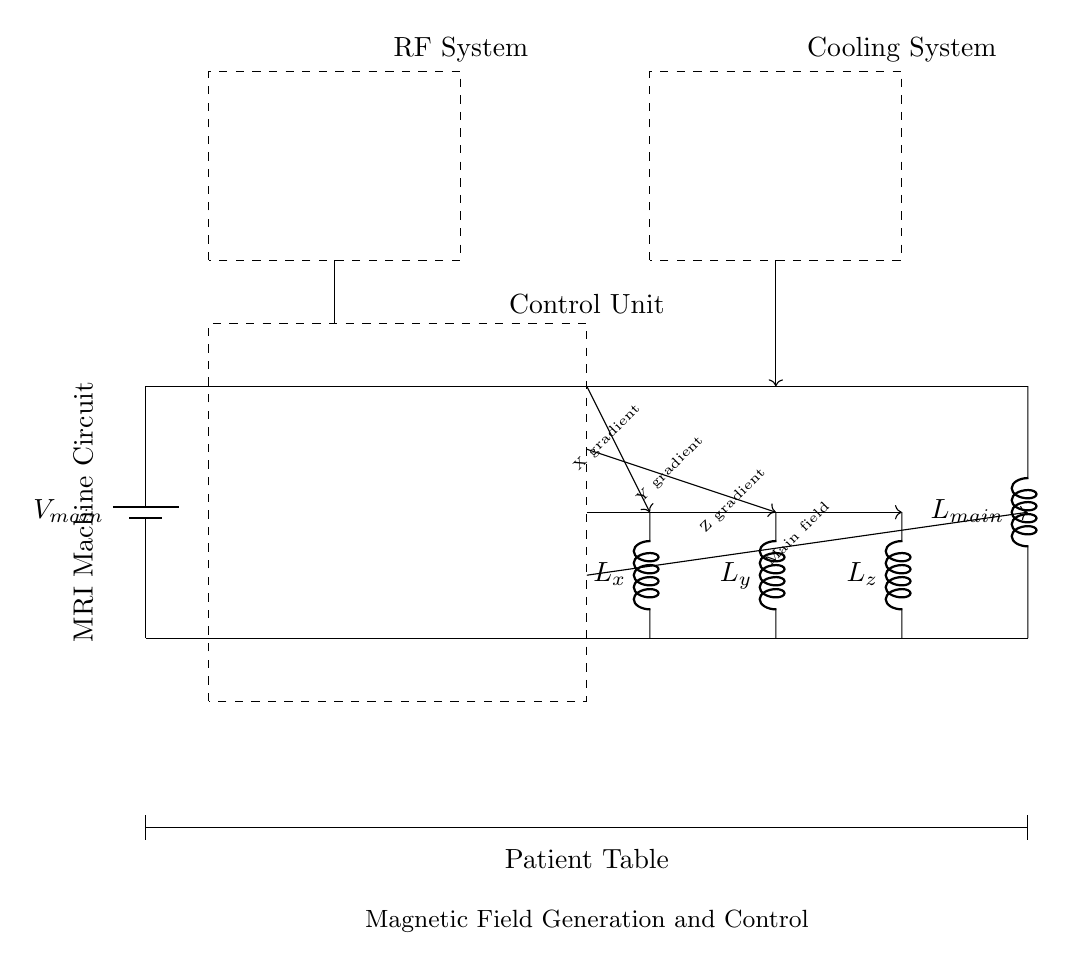What is the power supply voltage? The circuit diagram shows a battery labeled as V_main, which indicates the primary voltage source for the system.
Answer: V_main How many gradient coils are present in the circuit? The diagram clearly indicates three distinct inductors labeled as L_x, L_y, and L_z, representing the three gradient coils for X, Y, and Z directions respectively.
Answer: Three What is the function of the RF system in the circuit? The RF system is represented as a dashed rectangle located at the top left of the diagram. In MRI machines, the RF system is used for radiofrequency pulse generation and signal detection.
Answer: Radiofrequency pulse generation What do the arrows associated with the gradient coils represent? The arrows labeled X gradient, Y gradient, Z gradient, and Main field indicate control signals directing the operation of the respective coils for magnetic gradient generation. Each arrow points from the control unit to a specific coil.
Answer: Control signals What does the dashed rectangle labeled as "Cooling System" signify? The dashed rectangle labeled 'Cooling System' indicates a compartment necessary for maintaining the temperature of the MRI machine, particularly for the gradient coils, which generate heat during operation.
Answer: Temperature regulation Which component connects the main power supply to the rest of the circuit? The circuit connections show that the main power supply line connects directly to both the control unit and the main magnetic field coil, indicating it serves as the source for these components.
Answer: Main power supply What would happen if one of the gradient coils fails? If one of the gradient coils (L_x, L_y, or L_z) fails, the corresponding directional gradient generation would be compromised, which could lead to insufficient image resolution or distortions in MRI imaging.
Answer: Imaging distortions 